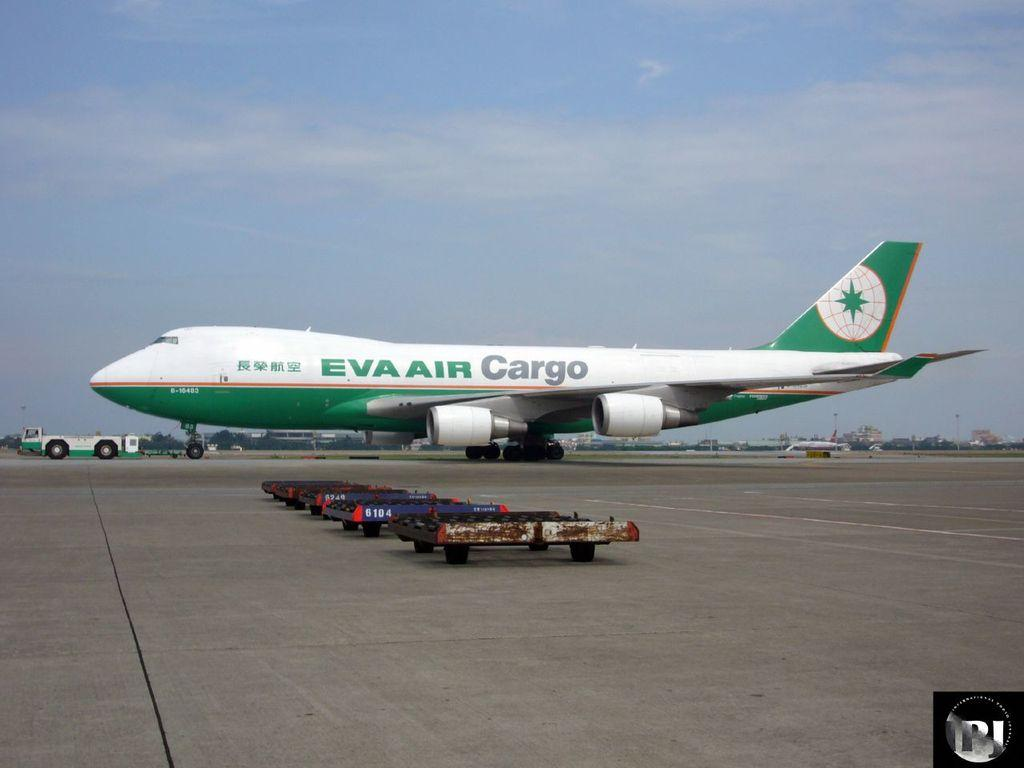Provide a one-sentence caption for the provided image. A large plane that is owned by Eva Air Cargo. 